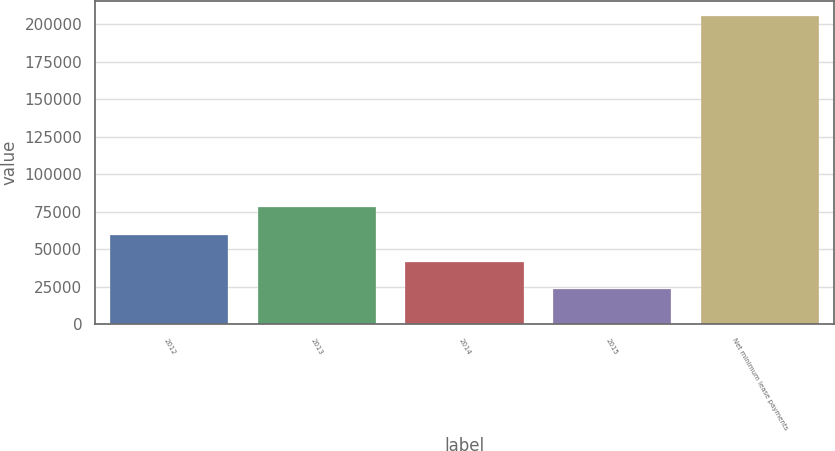Convert chart. <chart><loc_0><loc_0><loc_500><loc_500><bar_chart><fcel>2012<fcel>2013<fcel>2014<fcel>2015<fcel>Net minimum lease payments<nl><fcel>59628.8<fcel>77874.7<fcel>41382.9<fcel>23137<fcel>205596<nl></chart> 